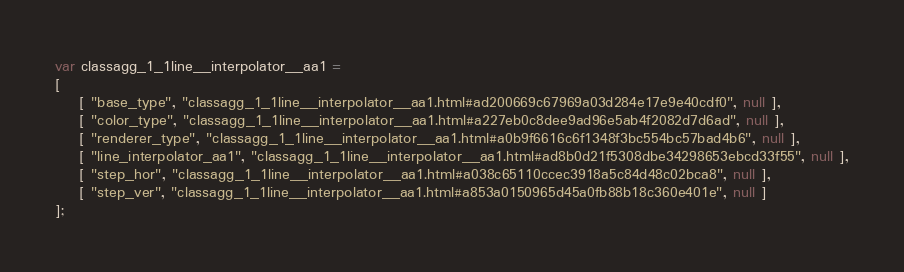<code> <loc_0><loc_0><loc_500><loc_500><_JavaScript_>var classagg_1_1line__interpolator__aa1 =
[
    [ "base_type", "classagg_1_1line__interpolator__aa1.html#ad200669c67969a03d284e17e9e40cdf0", null ],
    [ "color_type", "classagg_1_1line__interpolator__aa1.html#a227eb0c8dee9ad96e5ab4f2082d7d6ad", null ],
    [ "renderer_type", "classagg_1_1line__interpolator__aa1.html#a0b9f6616c6f1348f3bc554bc57bad4b6", null ],
    [ "line_interpolator_aa1", "classagg_1_1line__interpolator__aa1.html#ad8b0d21f5308dbe34298653ebcd33f55", null ],
    [ "step_hor", "classagg_1_1line__interpolator__aa1.html#a038c65110ccec3918a5c84d48c02bca8", null ],
    [ "step_ver", "classagg_1_1line__interpolator__aa1.html#a853a0150965d45a0fb88b18c360e401e", null ]
];</code> 